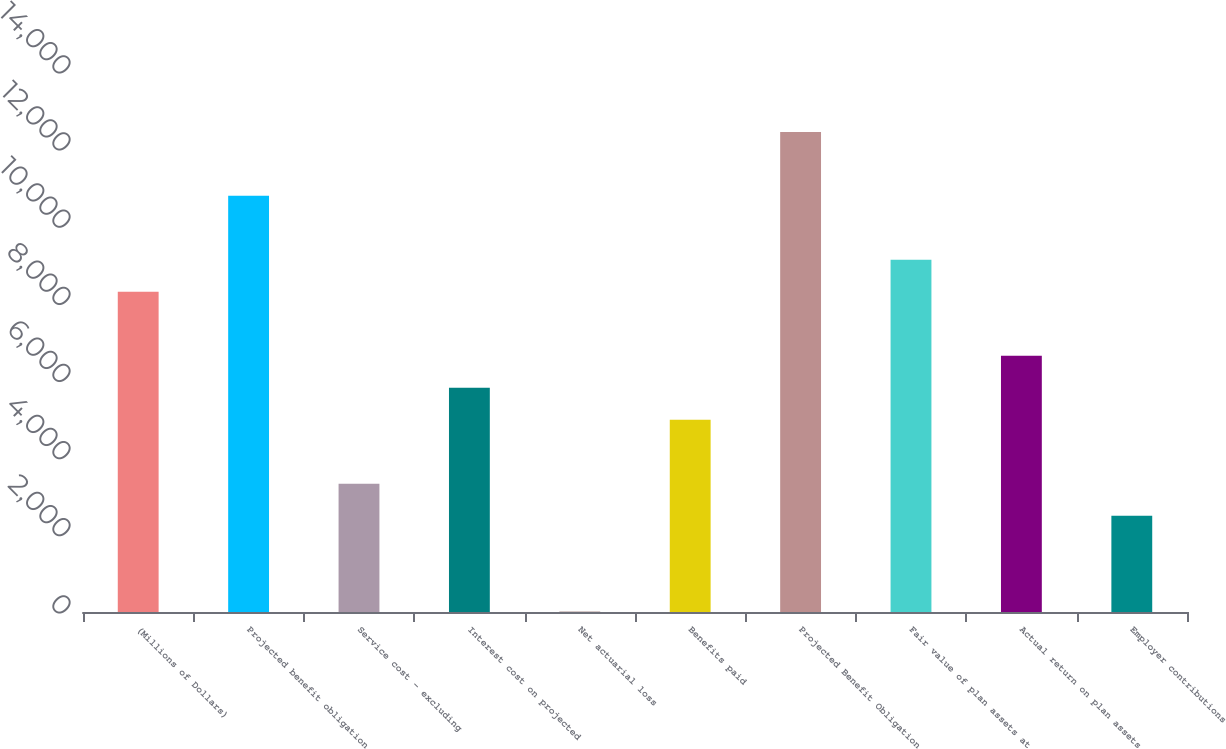<chart> <loc_0><loc_0><loc_500><loc_500><bar_chart><fcel>(Millions of Dollars)<fcel>Projected benefit obligation<fcel>Service cost - excluding<fcel>Interest cost on projected<fcel>Net actuarial loss<fcel>Benefits paid<fcel>Projected Benefit Obligation<fcel>Fair value of plan assets at<fcel>Actual return on plan assets<fcel>Employer contributions<nl><fcel>8300<fcel>10788.5<fcel>3323<fcel>5811.5<fcel>5<fcel>4982<fcel>12447.5<fcel>9129.5<fcel>6641<fcel>2493.5<nl></chart> 